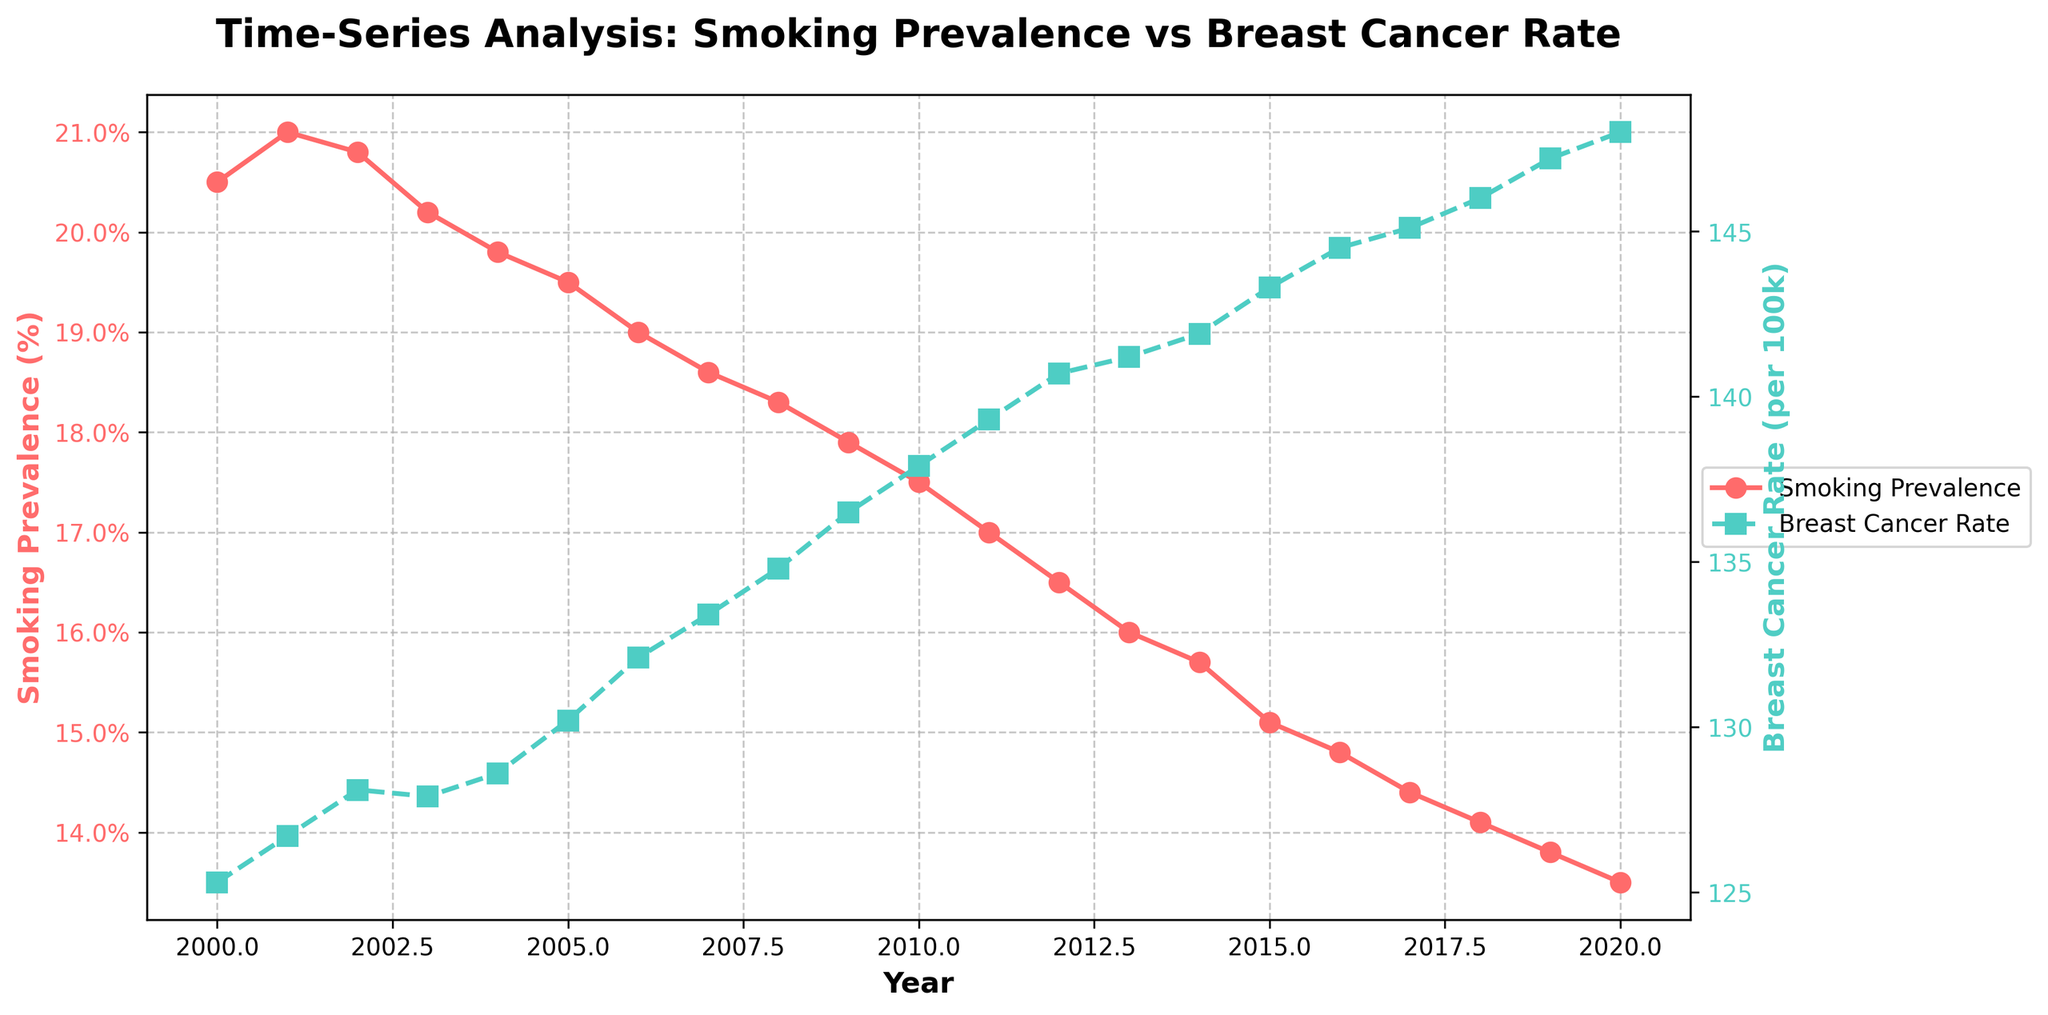What's the title of the figure? The title is displayed at the top of the figure and provides a summary of what the figure is about. It reads "Time-Series Analysis: Smoking Prevalence vs Breast Cancer Rate".
Answer: Time-Series Analysis: Smoking Prevalence vs Breast Cancer Rate What are the units of measurement for the y-axis on the left side of the figure? The y-axis on the left side of the figure measures smoking prevalence and is labeled as "Smoking Prevalence (%)".
Answer: Smoking Prevalence (%) How does the breast cancer rate change from 2000 to 2020? To understand this, observe the trend of the green line (with squares) from 2000 to 2020, which represents the breast cancer rate. The rate consistently increases from approximately 125.3 per 100k in 2000 to 148.0 per 100k in 2020.
Answer: It increases What was the value of smoking prevalence in 2010, and how does it compare to the prevalence in 2020? In 2010, look for the data point on the red line (with circles); it is 17.5%. In 2020, it is 13.5%. We compare these two values by calculating the difference: 17.5% - 13.5% = 4%.
Answer: 17.5% in 2010; decreased by 4% by 2020 What is the overall trend in smoking prevalence between 2000 and 2020? The red line (with circles) represents smoking prevalence. Observing its slope from 2000 to 2020 shows a steady decline.
Answer: Decreasing trend Between which consecutive years is the increase in breast cancer rate the highest? Look at the yearly increments of the green line (with squares). The greatest increase can be identified by comparing the slope differences year by year. From 2010 to 2011, the rate increases from 137.9 to 139.3, a difference of 1.4, which is the highest.
Answer: Between 2010 and 2011 Which year had the lowest smoking prevalence? To find the year with the lowest smoking prevalence, look for the lowest point on the red line (with circles). The lowest point is at the end, in the year 2020, which is 13.5%.
Answer: 2020 Compare the smoking prevalence in 2000 to the breast cancer rate in the same year. The value for smoking prevalence in 2000 is 20.5% (red line with circles), and the breast cancer rate is 125.3 per 100k (green line with squares).
Answer: 20.5% smoking prevalence and 125.3 per 100k breast cancer rate What can you infer about the relationship between smoking prevalence and breast cancer rate over the given time period? Observing the figure, smoking prevalence (red line) consistently decreases, while the breast cancer rate (green line) increases. This suggests an inverse relationship where lower smoking prevalence does not necessarily lead to lower breast cancer rates in this dataset.
Answer: Inverse relationship Determine the average annual decrease in smoking prevalence from 2000 to 2020. First, find the total decrease in smoking prevalence from 2000 to 2020: 20.5% - 13.5% = 7%. Over 20 years, this gives an average annual decrease: 7% / 20 = 0.35% per year.
Answer: 0.35% per year 